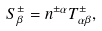<formula> <loc_0><loc_0><loc_500><loc_500>S ^ { \pm } _ { \beta } = n ^ { \pm \alpha } T ^ { \pm } _ { \alpha \beta } ,</formula> 